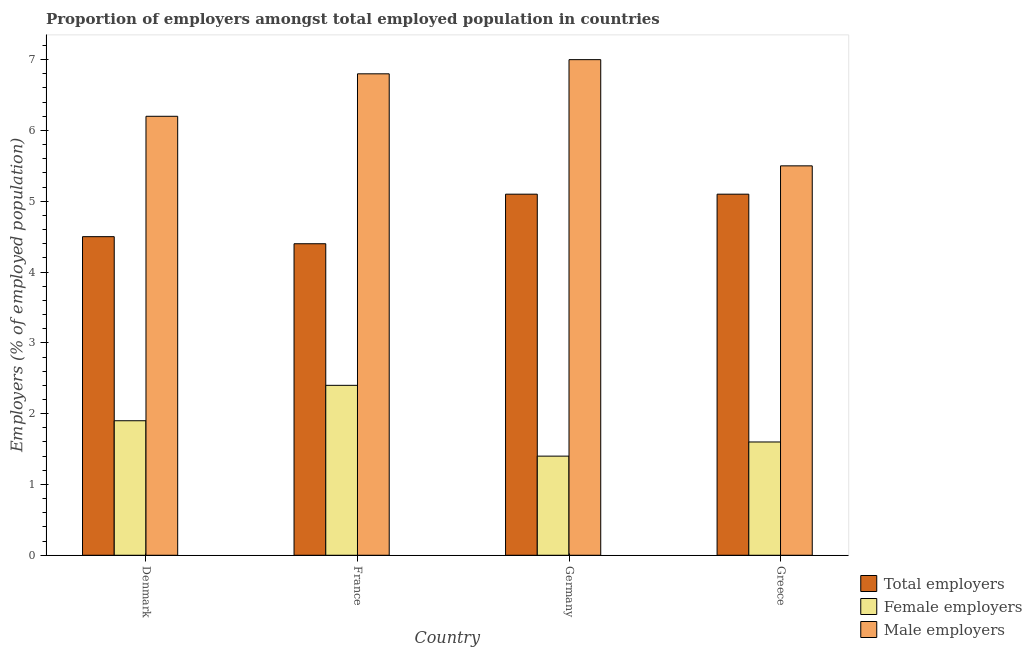How many groups of bars are there?
Ensure brevity in your answer.  4. Are the number of bars per tick equal to the number of legend labels?
Your response must be concise. Yes. What is the label of the 2nd group of bars from the left?
Give a very brief answer. France. In how many cases, is the number of bars for a given country not equal to the number of legend labels?
Your answer should be compact. 0. What is the percentage of total employers in France?
Offer a terse response. 4.4. Across all countries, what is the minimum percentage of total employers?
Your response must be concise. 4.4. In which country was the percentage of male employers minimum?
Your answer should be very brief. Greece. What is the total percentage of total employers in the graph?
Ensure brevity in your answer.  19.1. What is the difference between the percentage of male employers in Denmark and that in France?
Make the answer very short. -0.6. What is the difference between the percentage of male employers in Germany and the percentage of total employers in Greece?
Provide a succinct answer. 1.9. What is the average percentage of male employers per country?
Make the answer very short. 6.38. What is the difference between the percentage of male employers and percentage of female employers in France?
Make the answer very short. 4.4. What is the ratio of the percentage of female employers in Germany to that in Greece?
Offer a very short reply. 0.87. Is the percentage of male employers in Denmark less than that in Greece?
Ensure brevity in your answer.  No. What is the difference between the highest and the second highest percentage of male employers?
Provide a succinct answer. 0.2. What is the difference between the highest and the lowest percentage of female employers?
Keep it short and to the point. 1. Is the sum of the percentage of total employers in France and Greece greater than the maximum percentage of male employers across all countries?
Provide a succinct answer. Yes. What does the 3rd bar from the left in Germany represents?
Provide a short and direct response. Male employers. What does the 3rd bar from the right in France represents?
Provide a succinct answer. Total employers. How many bars are there?
Your response must be concise. 12. What is the difference between two consecutive major ticks on the Y-axis?
Your answer should be compact. 1. Are the values on the major ticks of Y-axis written in scientific E-notation?
Provide a short and direct response. No. Does the graph contain any zero values?
Your answer should be compact. No. Does the graph contain grids?
Make the answer very short. No. How many legend labels are there?
Keep it short and to the point. 3. How are the legend labels stacked?
Keep it short and to the point. Vertical. What is the title of the graph?
Offer a terse response. Proportion of employers amongst total employed population in countries. Does "Communicable diseases" appear as one of the legend labels in the graph?
Give a very brief answer. No. What is the label or title of the Y-axis?
Keep it short and to the point. Employers (% of employed population). What is the Employers (% of employed population) in Female employers in Denmark?
Provide a succinct answer. 1.9. What is the Employers (% of employed population) of Male employers in Denmark?
Ensure brevity in your answer.  6.2. What is the Employers (% of employed population) of Total employers in France?
Keep it short and to the point. 4.4. What is the Employers (% of employed population) of Female employers in France?
Offer a terse response. 2.4. What is the Employers (% of employed population) in Male employers in France?
Offer a very short reply. 6.8. What is the Employers (% of employed population) in Total employers in Germany?
Your response must be concise. 5.1. What is the Employers (% of employed population) in Female employers in Germany?
Your answer should be very brief. 1.4. What is the Employers (% of employed population) of Total employers in Greece?
Your response must be concise. 5.1. What is the Employers (% of employed population) of Female employers in Greece?
Offer a very short reply. 1.6. Across all countries, what is the maximum Employers (% of employed population) in Total employers?
Your response must be concise. 5.1. Across all countries, what is the maximum Employers (% of employed population) of Female employers?
Give a very brief answer. 2.4. Across all countries, what is the maximum Employers (% of employed population) in Male employers?
Your answer should be very brief. 7. Across all countries, what is the minimum Employers (% of employed population) in Total employers?
Your response must be concise. 4.4. Across all countries, what is the minimum Employers (% of employed population) in Female employers?
Offer a very short reply. 1.4. What is the total Employers (% of employed population) in Total employers in the graph?
Your response must be concise. 19.1. What is the total Employers (% of employed population) of Male employers in the graph?
Ensure brevity in your answer.  25.5. What is the difference between the Employers (% of employed population) in Total employers in Denmark and that in France?
Ensure brevity in your answer.  0.1. What is the difference between the Employers (% of employed population) in Female employers in Denmark and that in France?
Your response must be concise. -0.5. What is the difference between the Employers (% of employed population) in Male employers in Denmark and that in France?
Provide a short and direct response. -0.6. What is the difference between the Employers (% of employed population) in Total employers in Denmark and that in Germany?
Your answer should be compact. -0.6. What is the difference between the Employers (% of employed population) of Female employers in Denmark and that in Germany?
Ensure brevity in your answer.  0.5. What is the difference between the Employers (% of employed population) in Male employers in Denmark and that in Germany?
Your answer should be very brief. -0.8. What is the difference between the Employers (% of employed population) in Total employers in Denmark and that in Greece?
Your response must be concise. -0.6. What is the difference between the Employers (% of employed population) in Male employers in Denmark and that in Greece?
Provide a succinct answer. 0.7. What is the difference between the Employers (% of employed population) in Male employers in France and that in Germany?
Ensure brevity in your answer.  -0.2. What is the difference between the Employers (% of employed population) in Female employers in France and that in Greece?
Give a very brief answer. 0.8. What is the difference between the Employers (% of employed population) in Male employers in France and that in Greece?
Keep it short and to the point. 1.3. What is the difference between the Employers (% of employed population) in Total employers in Germany and that in Greece?
Make the answer very short. 0. What is the difference between the Employers (% of employed population) in Female employers in Denmark and the Employers (% of employed population) in Male employers in France?
Keep it short and to the point. -4.9. What is the difference between the Employers (% of employed population) of Total employers in Denmark and the Employers (% of employed population) of Female employers in Germany?
Give a very brief answer. 3.1. What is the difference between the Employers (% of employed population) of Female employers in Denmark and the Employers (% of employed population) of Male employers in Greece?
Ensure brevity in your answer.  -3.6. What is the difference between the Employers (% of employed population) of Total employers in France and the Employers (% of employed population) of Female employers in Greece?
Your response must be concise. 2.8. What is the difference between the Employers (% of employed population) of Total employers in France and the Employers (% of employed population) of Male employers in Greece?
Give a very brief answer. -1.1. What is the difference between the Employers (% of employed population) in Female employers in France and the Employers (% of employed population) in Male employers in Greece?
Your response must be concise. -3.1. What is the difference between the Employers (% of employed population) in Total employers in Germany and the Employers (% of employed population) in Male employers in Greece?
Ensure brevity in your answer.  -0.4. What is the difference between the Employers (% of employed population) of Female employers in Germany and the Employers (% of employed population) of Male employers in Greece?
Offer a terse response. -4.1. What is the average Employers (% of employed population) in Total employers per country?
Offer a terse response. 4.78. What is the average Employers (% of employed population) in Female employers per country?
Your answer should be very brief. 1.82. What is the average Employers (% of employed population) in Male employers per country?
Offer a very short reply. 6.38. What is the difference between the Employers (% of employed population) of Female employers and Employers (% of employed population) of Male employers in Denmark?
Keep it short and to the point. -4.3. What is the difference between the Employers (% of employed population) in Total employers and Employers (% of employed population) in Female employers in France?
Your answer should be compact. 2. What is the difference between the Employers (% of employed population) of Total employers and Employers (% of employed population) of Female employers in Germany?
Offer a terse response. 3.7. What is the difference between the Employers (% of employed population) in Total employers and Employers (% of employed population) in Male employers in Germany?
Offer a very short reply. -1.9. What is the difference between the Employers (% of employed population) of Total employers and Employers (% of employed population) of Female employers in Greece?
Provide a succinct answer. 3.5. What is the ratio of the Employers (% of employed population) in Total employers in Denmark to that in France?
Keep it short and to the point. 1.02. What is the ratio of the Employers (% of employed population) of Female employers in Denmark to that in France?
Your response must be concise. 0.79. What is the ratio of the Employers (% of employed population) in Male employers in Denmark to that in France?
Ensure brevity in your answer.  0.91. What is the ratio of the Employers (% of employed population) in Total employers in Denmark to that in Germany?
Provide a short and direct response. 0.88. What is the ratio of the Employers (% of employed population) of Female employers in Denmark to that in Germany?
Your answer should be very brief. 1.36. What is the ratio of the Employers (% of employed population) of Male employers in Denmark to that in Germany?
Give a very brief answer. 0.89. What is the ratio of the Employers (% of employed population) in Total employers in Denmark to that in Greece?
Give a very brief answer. 0.88. What is the ratio of the Employers (% of employed population) in Female employers in Denmark to that in Greece?
Your answer should be very brief. 1.19. What is the ratio of the Employers (% of employed population) in Male employers in Denmark to that in Greece?
Provide a short and direct response. 1.13. What is the ratio of the Employers (% of employed population) of Total employers in France to that in Germany?
Provide a succinct answer. 0.86. What is the ratio of the Employers (% of employed population) of Female employers in France to that in Germany?
Make the answer very short. 1.71. What is the ratio of the Employers (% of employed population) in Male employers in France to that in Germany?
Your response must be concise. 0.97. What is the ratio of the Employers (% of employed population) in Total employers in France to that in Greece?
Your answer should be very brief. 0.86. What is the ratio of the Employers (% of employed population) in Male employers in France to that in Greece?
Offer a very short reply. 1.24. What is the ratio of the Employers (% of employed population) of Female employers in Germany to that in Greece?
Offer a very short reply. 0.88. What is the ratio of the Employers (% of employed population) of Male employers in Germany to that in Greece?
Provide a short and direct response. 1.27. What is the difference between the highest and the second highest Employers (% of employed population) in Total employers?
Provide a short and direct response. 0. What is the difference between the highest and the second highest Employers (% of employed population) in Female employers?
Keep it short and to the point. 0.5. What is the difference between the highest and the second highest Employers (% of employed population) in Male employers?
Your response must be concise. 0.2. What is the difference between the highest and the lowest Employers (% of employed population) in Total employers?
Your answer should be compact. 0.7. 